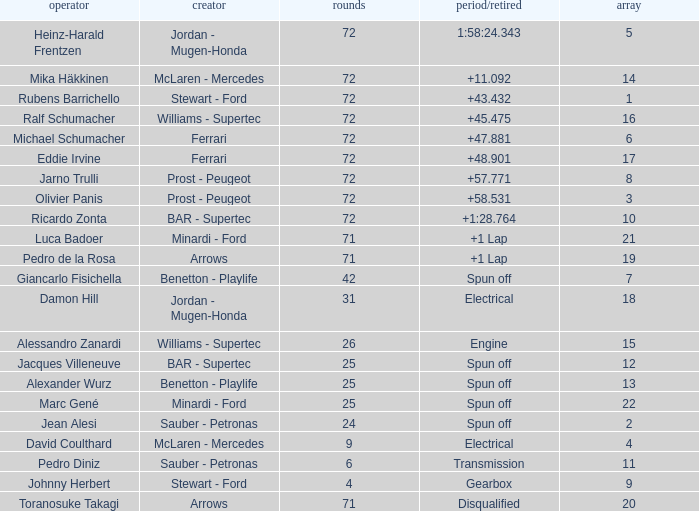When Jean Alesi had laps less than 24, what was his highest grid? None. 